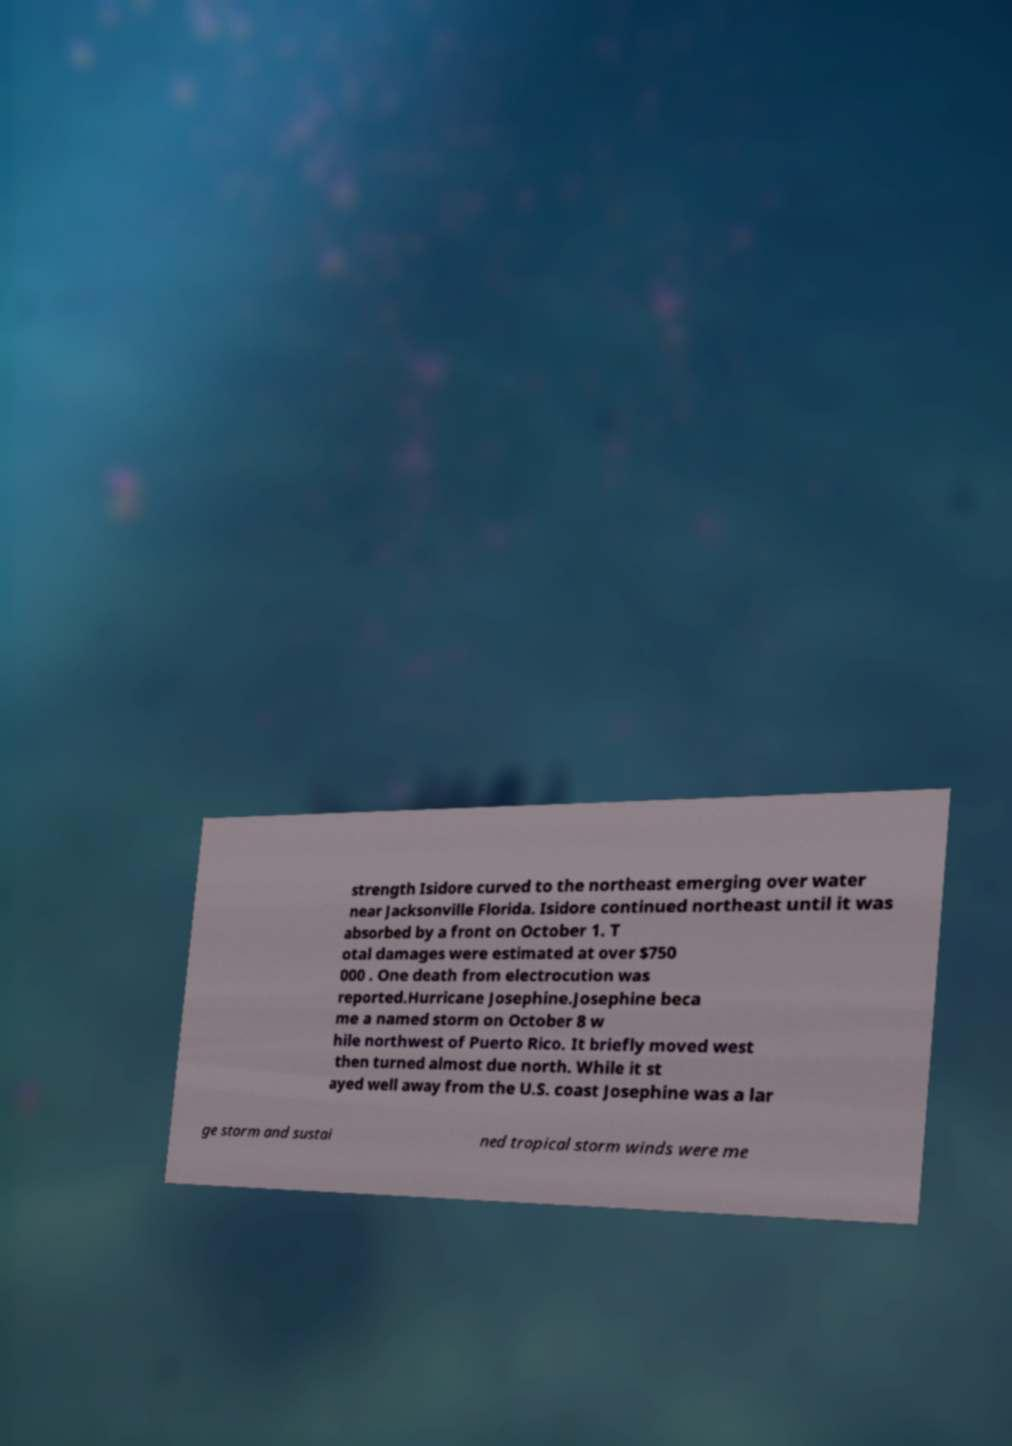For documentation purposes, I need the text within this image transcribed. Could you provide that? strength Isidore curved to the northeast emerging over water near Jacksonville Florida. Isidore continued northeast until it was absorbed by a front on October 1. T otal damages were estimated at over $750 000 . One death from electrocution was reported.Hurricane Josephine.Josephine beca me a named storm on October 8 w hile northwest of Puerto Rico. It briefly moved west then turned almost due north. While it st ayed well away from the U.S. coast Josephine was a lar ge storm and sustai ned tropical storm winds were me 